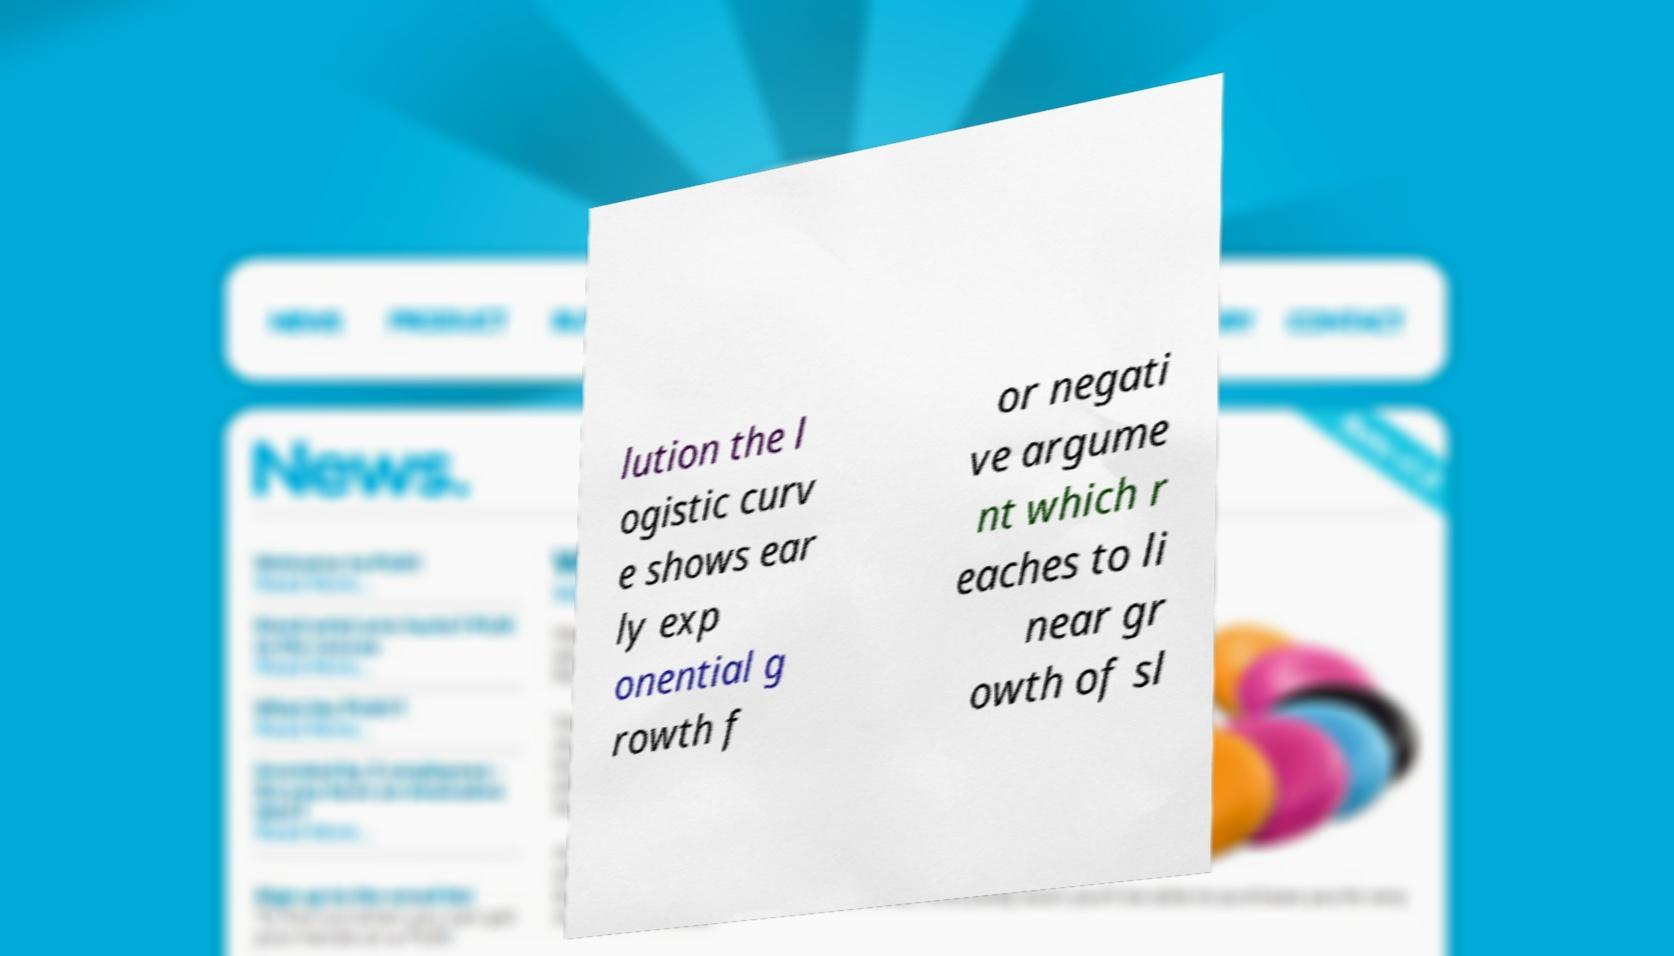There's text embedded in this image that I need extracted. Can you transcribe it verbatim? lution the l ogistic curv e shows ear ly exp onential g rowth f or negati ve argume nt which r eaches to li near gr owth of sl 